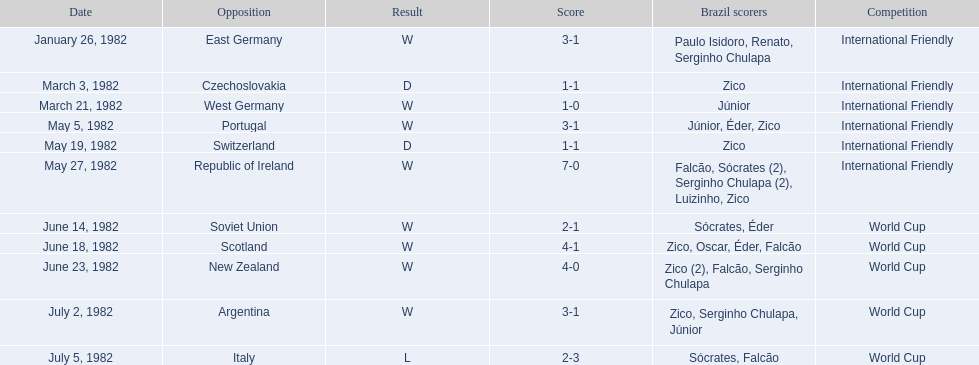What were the scores of each of game in the 1982 brazilian football games? 3-1, 1-1, 1-0, 3-1, 1-1, 7-0, 2-1, 4-1, 4-0, 3-1, 2-3. Of those, which were scores from games against portugal and the soviet union? 3-1, 2-1. And between those two games, against which country did brazil score more goals? Portugal. 